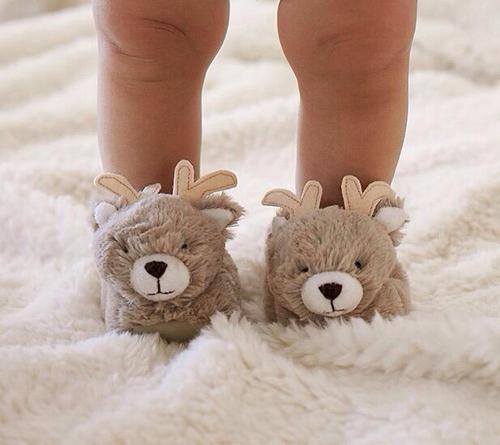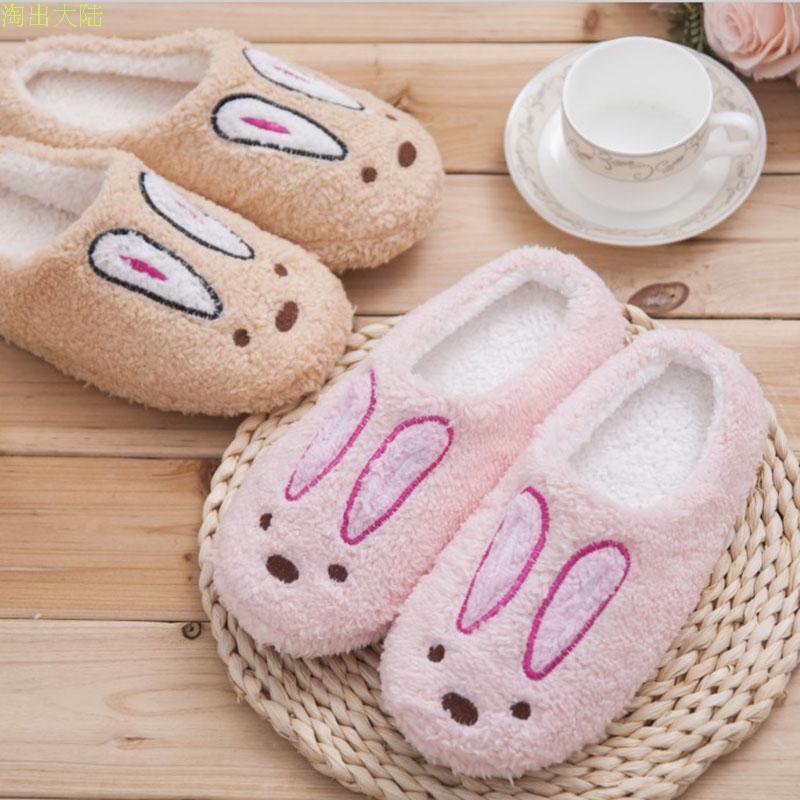The first image is the image on the left, the second image is the image on the right. Considering the images on both sides, is "The combined images include two pairs of fuzzy slippers with bunny-rabbit faces." valid? Answer yes or no. Yes. 